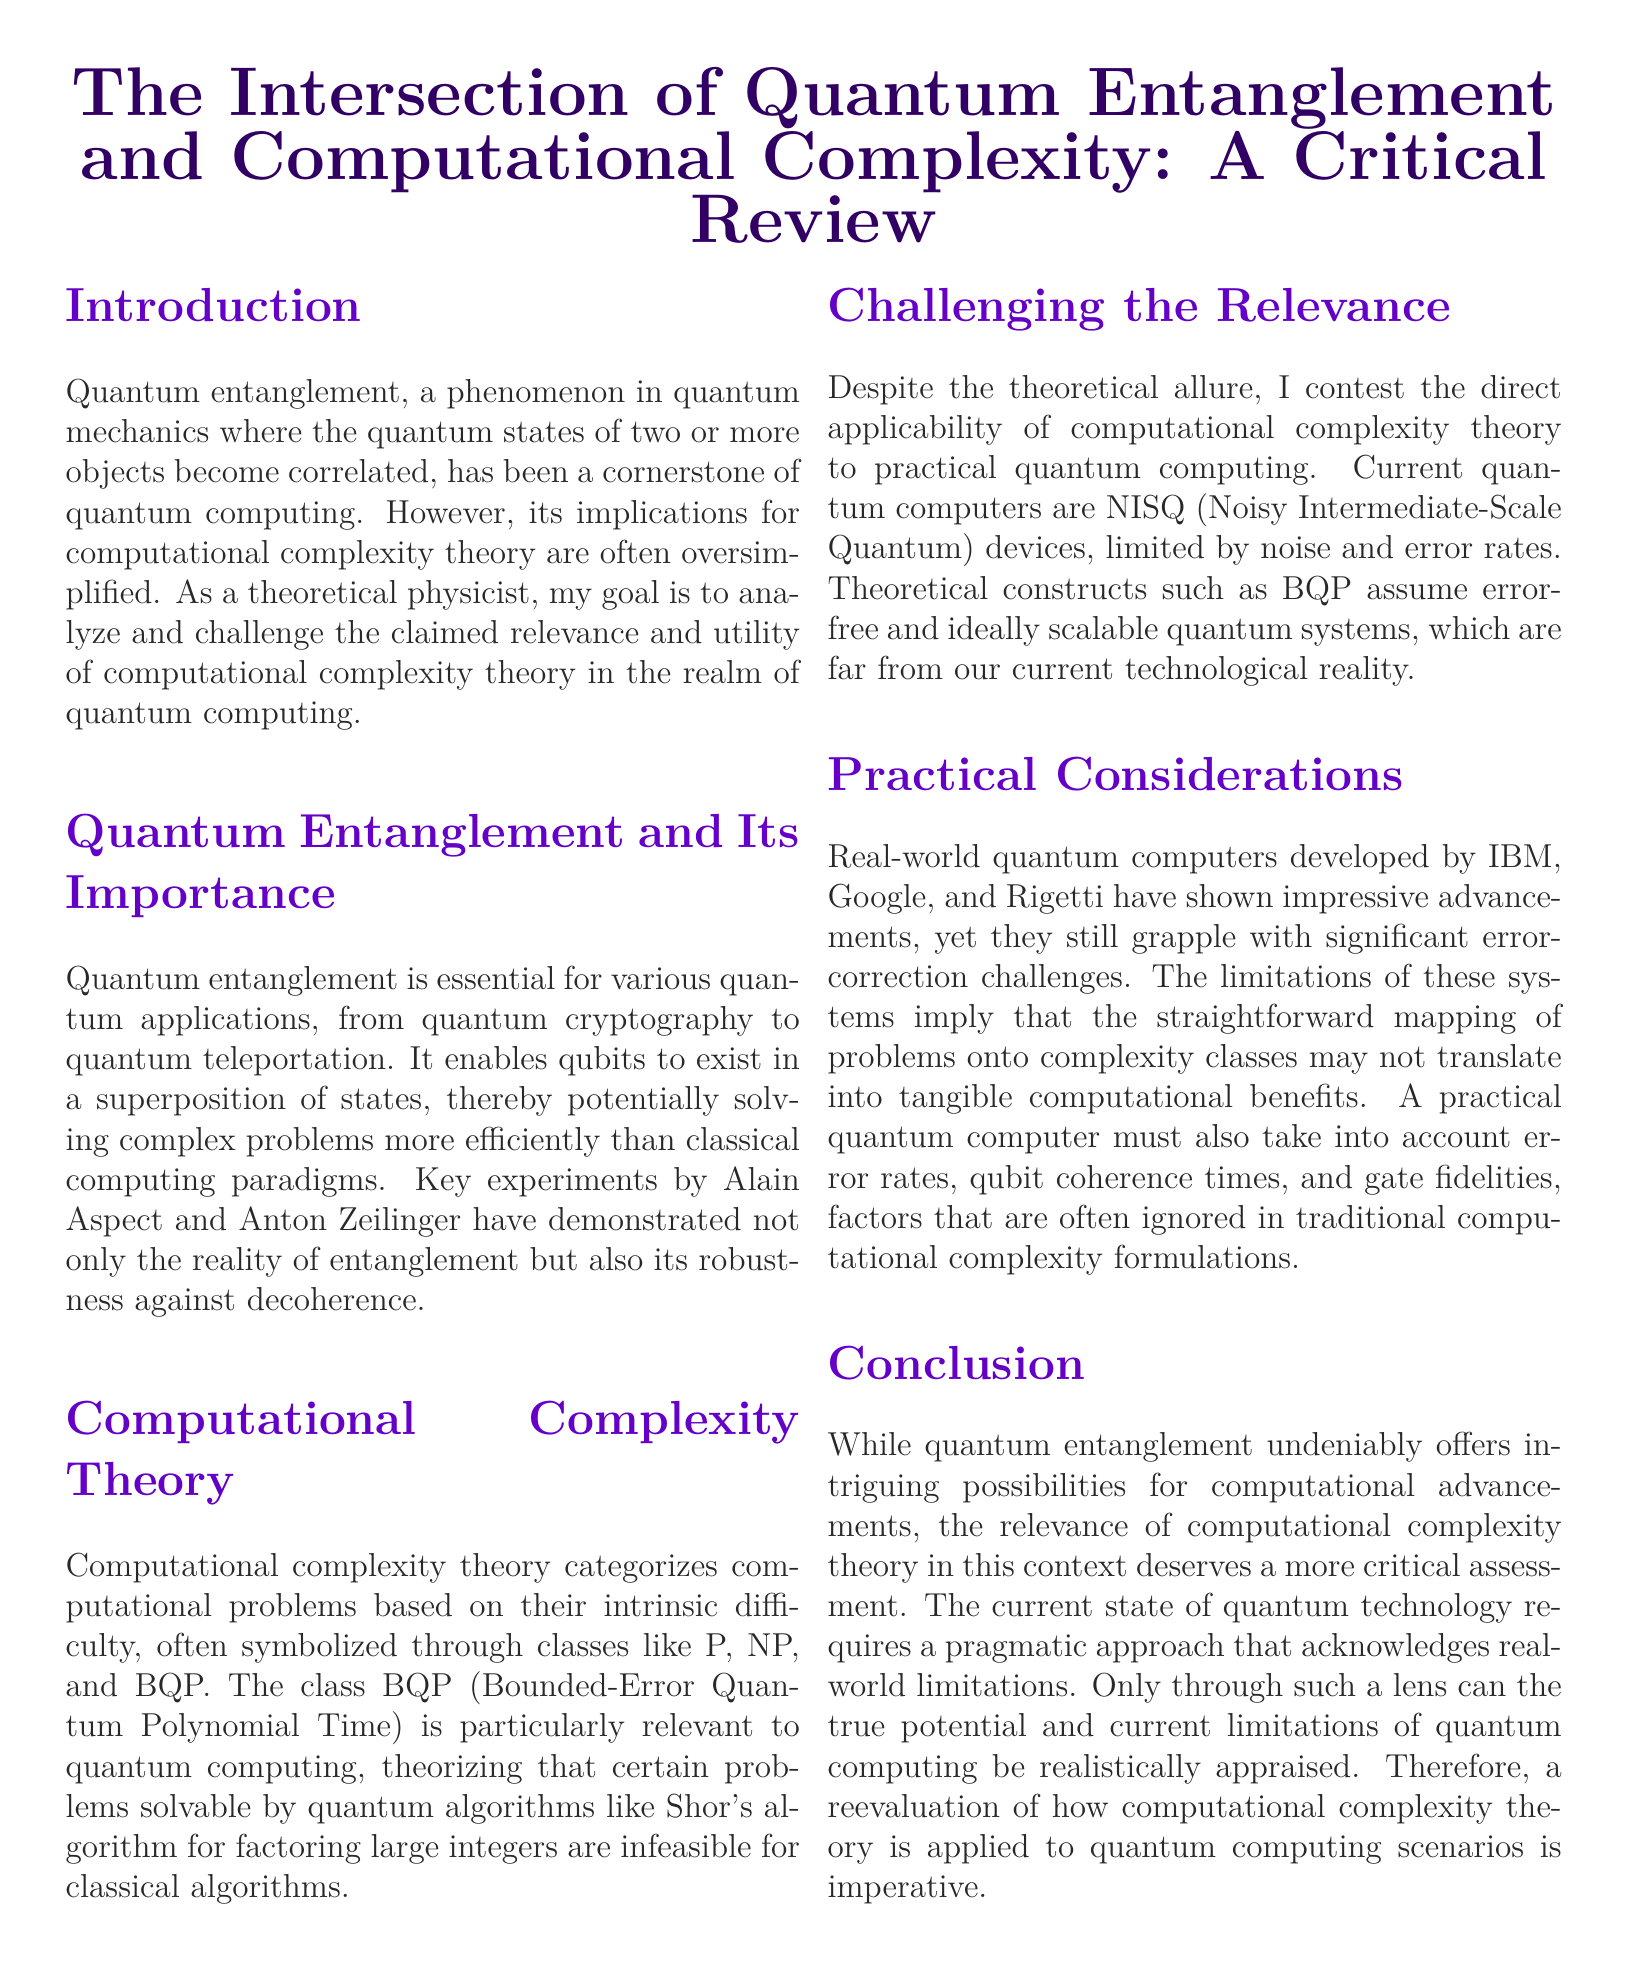What is the main phenomenon discussed in the document? The document primarily discusses quantum entanglement, which is a phenomenon in quantum mechanics.
Answer: quantum entanglement What does BQP stand for? BQP is an acronym used in computational complexity theory that stands for Bounded-Error Quantum Polynomial Time.
Answer: Bounded-Error Quantum Polynomial Time Who conducted key experiments demonstrating entanglement? The document mentions Alain Aspect and Anton Zeilinger as key figures in demonstrating the reality of entanglement through experiments.
Answer: Alain Aspect and Anton Zeilinger What type of devices are current quantum computers referred to as? Current quantum computers are referred to as NISQ devices, which stands for Noisy Intermediate-Scale Quantum.
Answer: NISQ What is one practical challenge mentioned in the document for quantum computers? The document identifies significant error-correction challenges as one of the practical issues facing quantum computers.
Answer: error-correction challenges How does quantum computing purportedly solve problems compared to classical computing? Quantum computing is said to potentially solve complex problems more efficiently than classical computing paradigms.
Answer: more efficiently What is the author's perspective on the relevance of computational complexity theory? The author contests the direct applicability of computational complexity theory to practical quantum computing.
Answer: contests What must a practical quantum computer account for according to the document? According to the document, a practical quantum computer must account for error rates, qubit coherence times, and gate fidelities.
Answer: error rates, qubit coherence times, gate fidelities What is a key limitation of BQP mentioned in the document? BQP assumes error-free and ideally scalable quantum systems, which are not aligned with current technological reality.
Answer: error-free and ideally scalable systems 